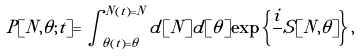Convert formula to latex. <formula><loc_0><loc_0><loc_500><loc_500>P [ N , \theta ; t ] = \int _ { \theta ( t ) = \theta } ^ { N ( t ) = N } d [ N ] d [ \theta ] \exp \left \{ \frac { i } { } S [ N , \theta ] \right \} ,</formula> 